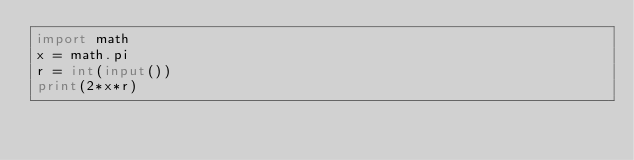<code> <loc_0><loc_0><loc_500><loc_500><_Python_>import math
x = math.pi
r = int(input())
print(2*x*r)</code> 